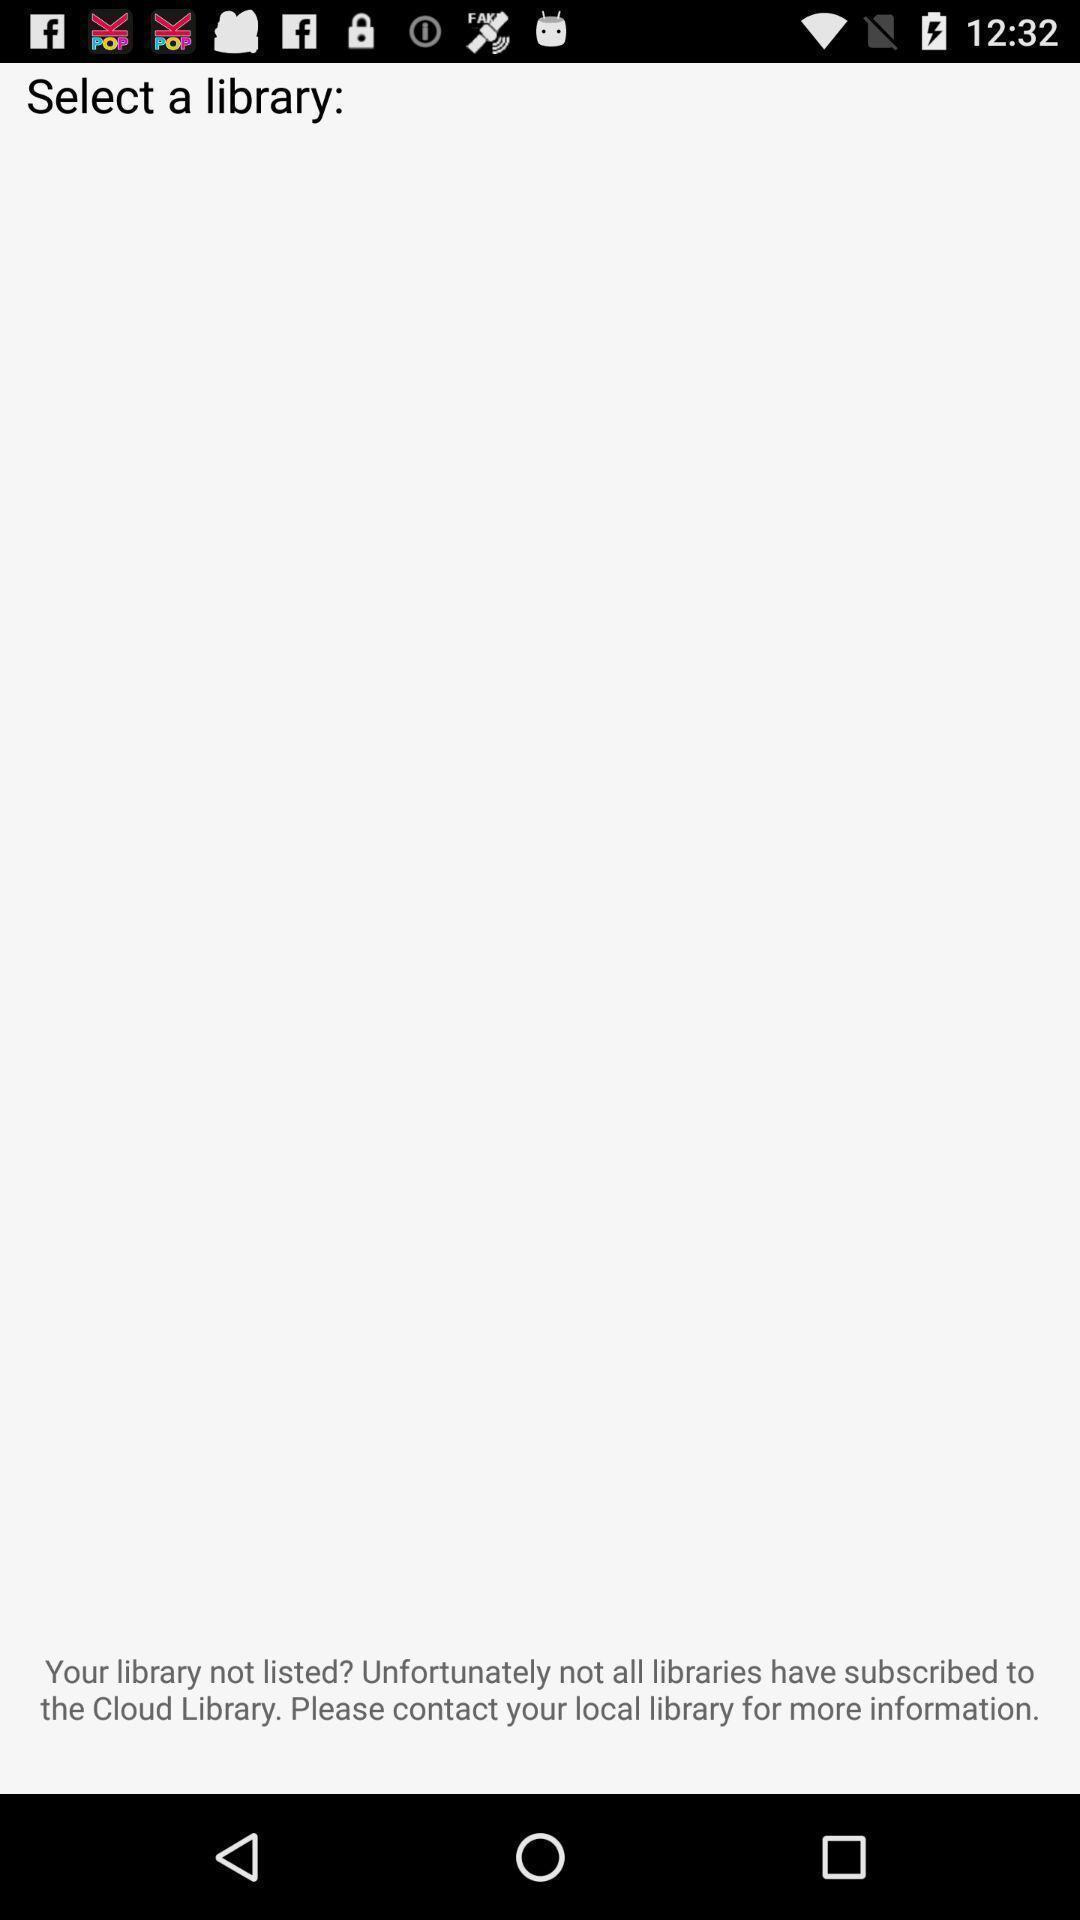Describe this image in words. Page shows the selecting option of a library. 